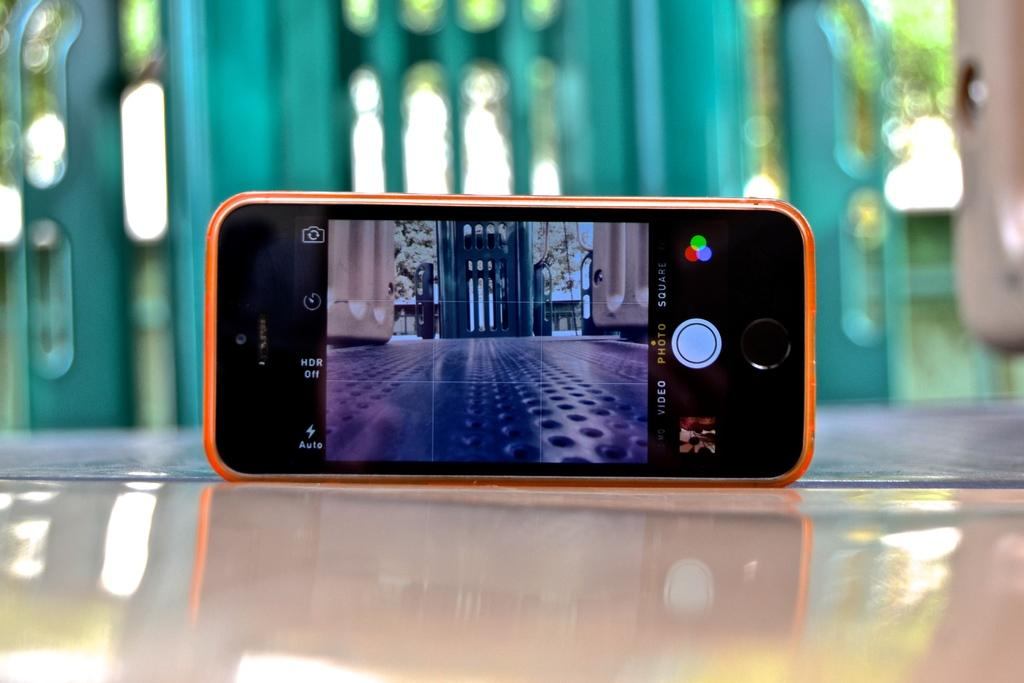<image>
Summarize the visual content of the image. a cell phone is set up to camera mode with the flash set to auto 